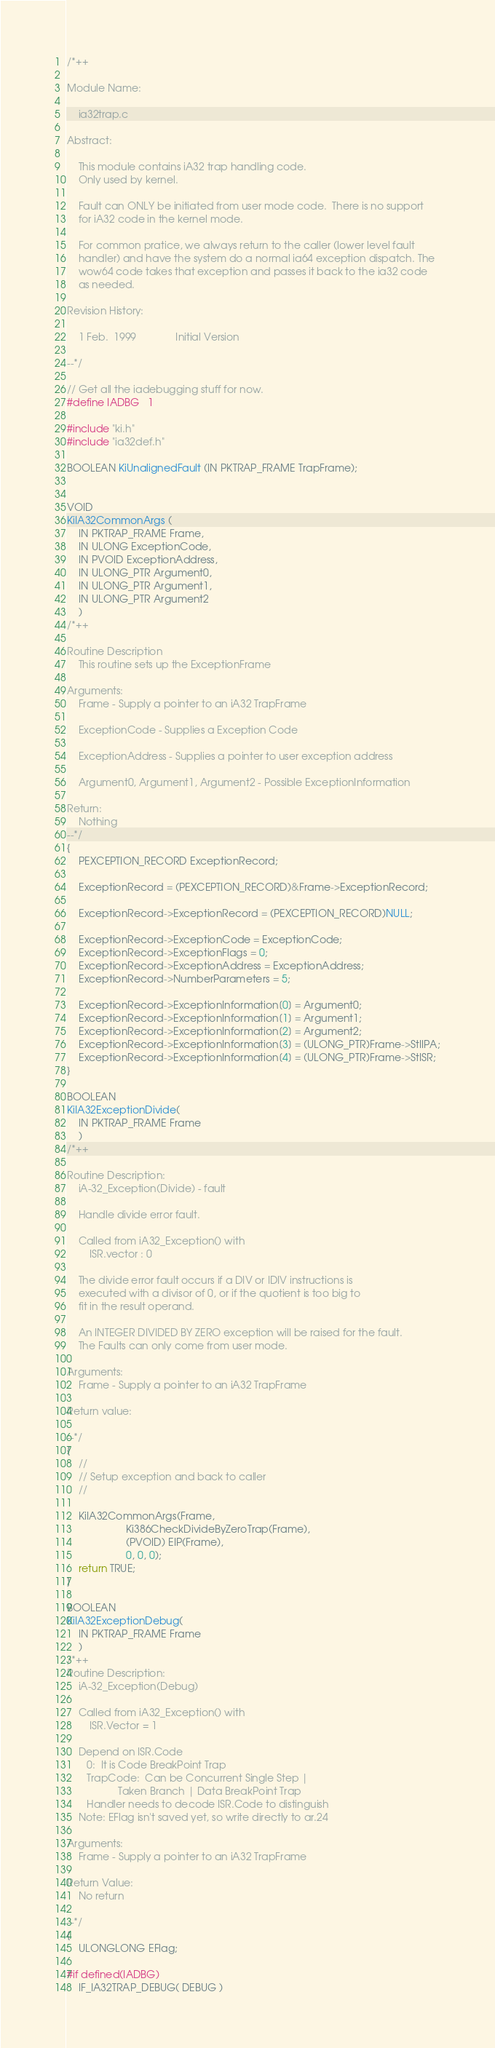Convert code to text. <code><loc_0><loc_0><loc_500><loc_500><_C_>/*++

Module Name:
        
    ia32trap.c

Abstract:

    This module contains iA32 trap handling code.
    Only used by kernel.

    Fault can ONLY be initiated from user mode code.  There is no support
    for iA32 code in the kernel mode.

    For common pratice, we always return to the caller (lower level fault
    handler) and have the system do a normal ia64 exception dispatch. The
    wow64 code takes that exception and passes it back to the ia32 code
    as needed.

Revision History:

    1 Feb.  1999              Initial Version

--*/

// Get all the iadebugging stuff for now.
#define IADBG   1

#include "ki.h"
#include "ia32def.h"

BOOLEAN KiUnalignedFault (IN PKTRAP_FRAME TrapFrame);


VOID
KiIA32CommonArgs (
    IN PKTRAP_FRAME Frame,
    IN ULONG ExceptionCode,
    IN PVOID ExceptionAddress,
    IN ULONG_PTR Argument0,
    IN ULONG_PTR Argument1,
    IN ULONG_PTR Argument2
    )
/*++

Routine Description
    This routine sets up the ExceptionFrame 

Arguments:
    Frame - Supply a pointer to an iA32 TrapFrame

    ExceptionCode - Supplies a Exception Code

    ExceptionAddress - Supplies a pointer to user exception address

    Argument0, Argument1, Argument2 - Possible ExceptionInformation

Return:
    Nothing
--*/
{
    PEXCEPTION_RECORD ExceptionRecord;

    ExceptionRecord = (PEXCEPTION_RECORD)&Frame->ExceptionRecord;

    ExceptionRecord->ExceptionRecord = (PEXCEPTION_RECORD)NULL;

    ExceptionRecord->ExceptionCode = ExceptionCode;
    ExceptionRecord->ExceptionFlags = 0;
    ExceptionRecord->ExceptionAddress = ExceptionAddress;
    ExceptionRecord->NumberParameters = 5;
       
    ExceptionRecord->ExceptionInformation[0] = Argument0;
    ExceptionRecord->ExceptionInformation[1] = Argument1;
    ExceptionRecord->ExceptionInformation[2] = Argument2;
    ExceptionRecord->ExceptionInformation[3] = (ULONG_PTR)Frame->StIIPA;
    ExceptionRecord->ExceptionInformation[4] = (ULONG_PTR)Frame->StISR;
}

BOOLEAN
KiIA32ExceptionDivide(
    IN PKTRAP_FRAME Frame
    )
/*++

Routine Description:
    iA-32_Exception(Divide) - fault

    Handle divide error fault.

    Called from iA32_Exception() with 
        ISR.vector : 0

    The divide error fault occurs if a DIV or IDIV instructions is
    executed with a divisor of 0, or if the quotient is too big to
    fit in the result operand.

    An INTEGER DIVIDED BY ZERO exception will be raised for the fault.
    The Faults can only come from user mode.

Arguments:
    Frame - Supply a pointer to an iA32 TrapFrame

Return value:

--*/
{
    // 
    // Setup exception and back to caller
    //

    KiIA32CommonArgs(Frame,
                     Ki386CheckDivideByZeroTrap(Frame),
                     (PVOID) EIP(Frame),
                     0, 0, 0);
    return TRUE;
}

BOOLEAN
KiIA32ExceptionDebug(
    IN PKTRAP_FRAME Frame
    )
/*++
Routine Description:
    iA-32_Exception(Debug)

    Called from iA32_Exception() with
        ISR.Vector = 1

    Depend on ISR.Code
       0:  It is Code BreakPoint Trap
       TrapCode:  Can be Concurrent Single Step | 
                  Taken Branch | Data BreakPoint Trap
       Handler needs to decode ISR.Code to distinguish
    Note: EFlag isn't saved yet, so write directly to ar.24

Arguments:
    Frame - Supply a pointer to an iA32 TrapFrame

Return Value:
    No return

--*/
{
    ULONGLONG EFlag;

#if defined(IADBG)
    IF_IA32TRAP_DEBUG( DEBUG )</code> 